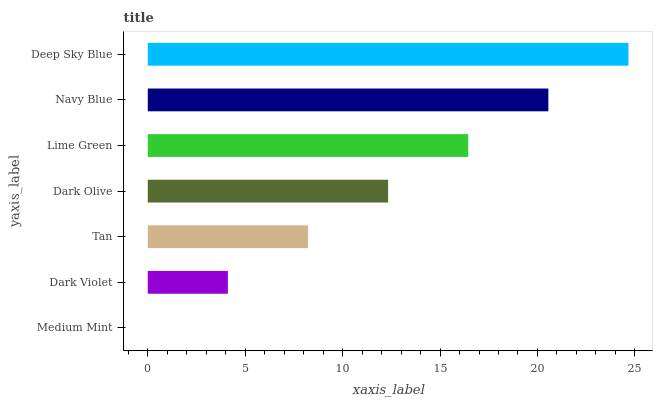Is Medium Mint the minimum?
Answer yes or no. Yes. Is Deep Sky Blue the maximum?
Answer yes or no. Yes. Is Dark Violet the minimum?
Answer yes or no. No. Is Dark Violet the maximum?
Answer yes or no. No. Is Dark Violet greater than Medium Mint?
Answer yes or no. Yes. Is Medium Mint less than Dark Violet?
Answer yes or no. Yes. Is Medium Mint greater than Dark Violet?
Answer yes or no. No. Is Dark Violet less than Medium Mint?
Answer yes or no. No. Is Dark Olive the high median?
Answer yes or no. Yes. Is Dark Olive the low median?
Answer yes or no. Yes. Is Deep Sky Blue the high median?
Answer yes or no. No. Is Navy Blue the low median?
Answer yes or no. No. 